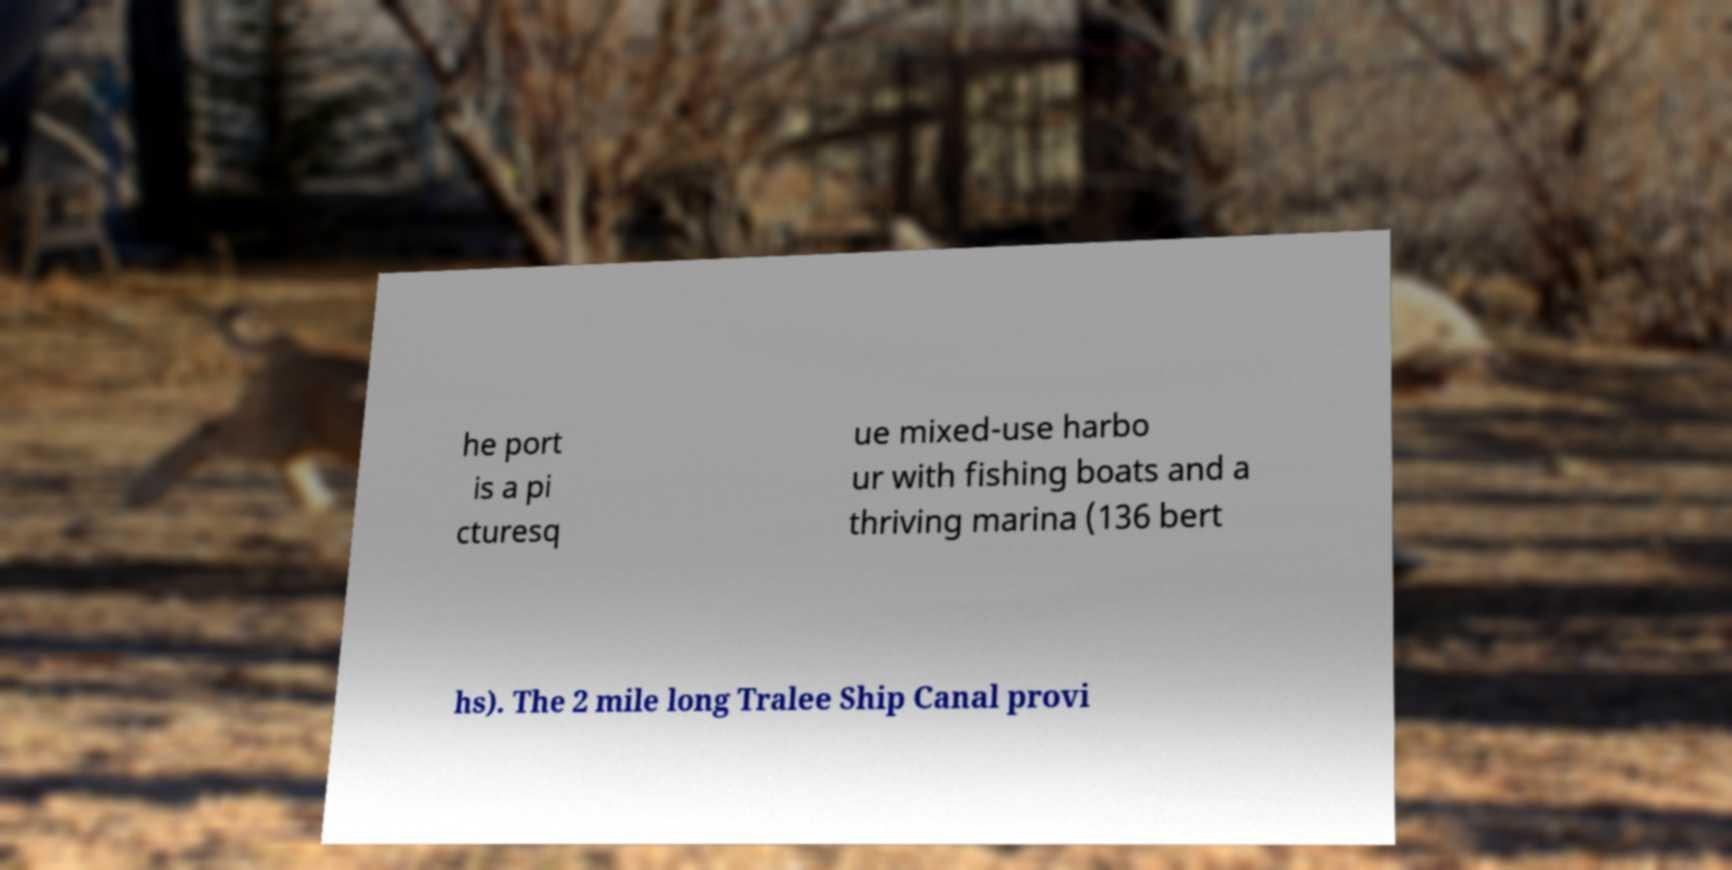There's text embedded in this image that I need extracted. Can you transcribe it verbatim? he port is a pi cturesq ue mixed-use harbo ur with fishing boats and a thriving marina (136 bert hs). The 2 mile long Tralee Ship Canal provi 